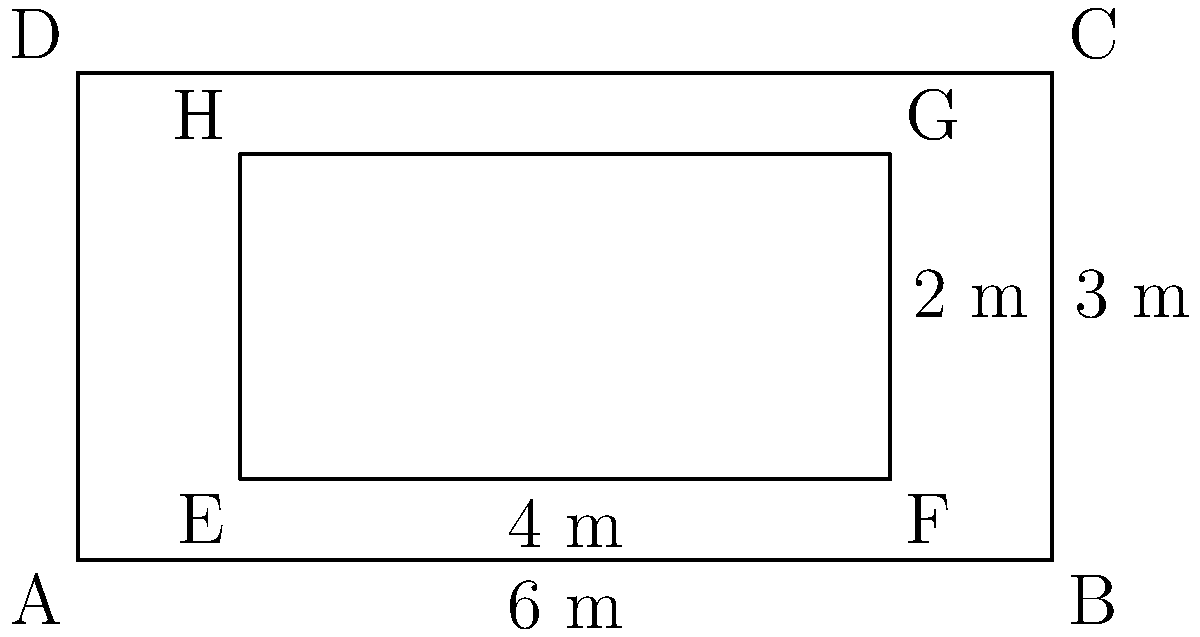At El Sadar stadium, home of CA Osasuna, rectangular advertising boards are placed around the pitch. If the outer rectangle ABCD represents the pitch dimensions and the inner rectangle EFGH represents an advertising board, prove that triangles AED and BGC are congruent. To prove that triangles AED and BGC are congruent, we'll use the ASA (Angle-Side-Angle) congruence criterion. Let's follow these steps:

1) First, we need to show that ∠DAE ≅ ∠CBG:
   - ∠DAB and ∠BCA are right angles (90°) as they are corners of a rectangle.
   - ∠EAD and ∠GCB are also right angles for the same reason.
   - Therefore, ∠DAE = ∠CBG = 90° - 90° = 0°

2) Next, we'll prove that AE ≅ BG:
   - AB = 6 m (given)
   - EF = 4 m (given)
   - AE = BG = (AB - EF) / 2 = (6 - 4) / 2 = 1 m

3) Finally, we'll show that AD ≅ BC:
   - AD and BC are opposite sides of rectangle ABCD
   - In a rectangle, opposite sides are equal
   - Therefore, AD = BC = 3 m (given)

4) Now we have:
   - ∠DAE ≅ ∠CBG (proved in step 1)
   - AE ≅ BG (proved in step 2)
   - AD ≅ BC (proved in step 3)

5) By the ASA congruence criterion, if two angles and the included side of one triangle are congruent to the corresponding parts of another triangle, the triangles are congruent.

Therefore, triangle AED is congruent to triangle BGC.
Answer: ASA congruence: ∠DAE ≅ ∠CBG, AE ≅ BG, AD ≅ BC 